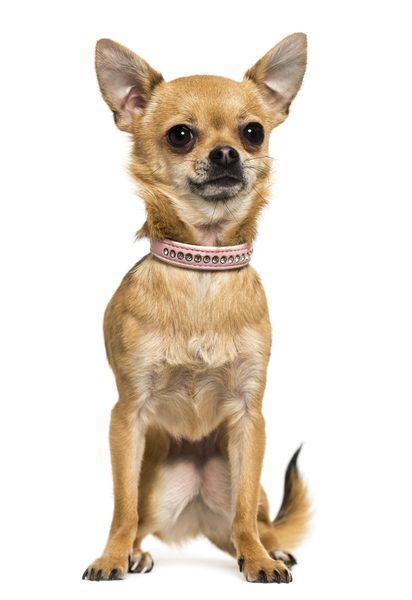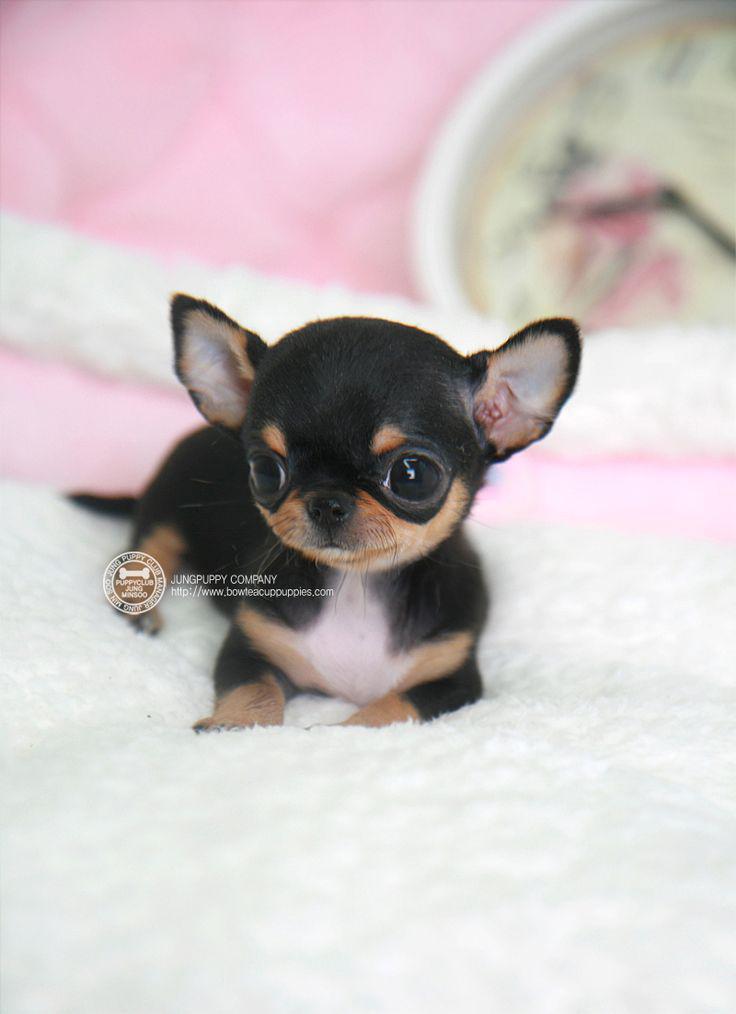The first image is the image on the left, the second image is the image on the right. Evaluate the accuracy of this statement regarding the images: "The left image contains at least three chihuahuas sitting in a horizontal row.". Is it true? Answer yes or no. No. The first image is the image on the left, the second image is the image on the right. Considering the images on both sides, is "In one image, a very small dog is inside of a teacup" valid? Answer yes or no. No. 